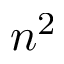Convert formula to latex. <formula><loc_0><loc_0><loc_500><loc_500>n ^ { 2 }</formula> 